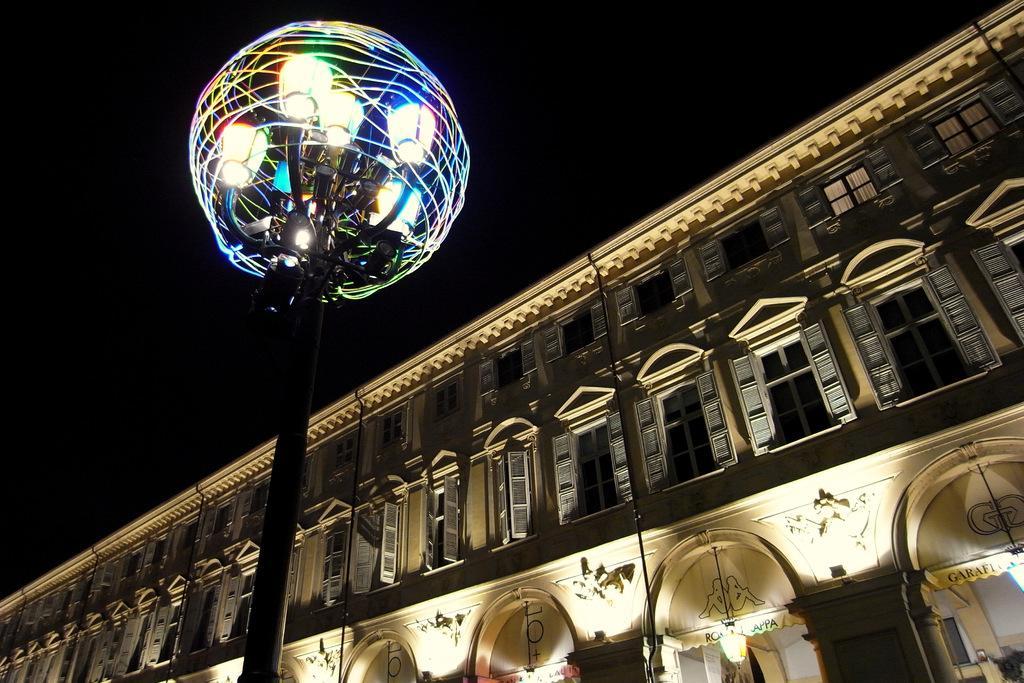How would you summarize this image in a sentence or two? In this image there is a building on the right side. To the building there are so many windows. In the middle there is a pole to which there are so many lights. 